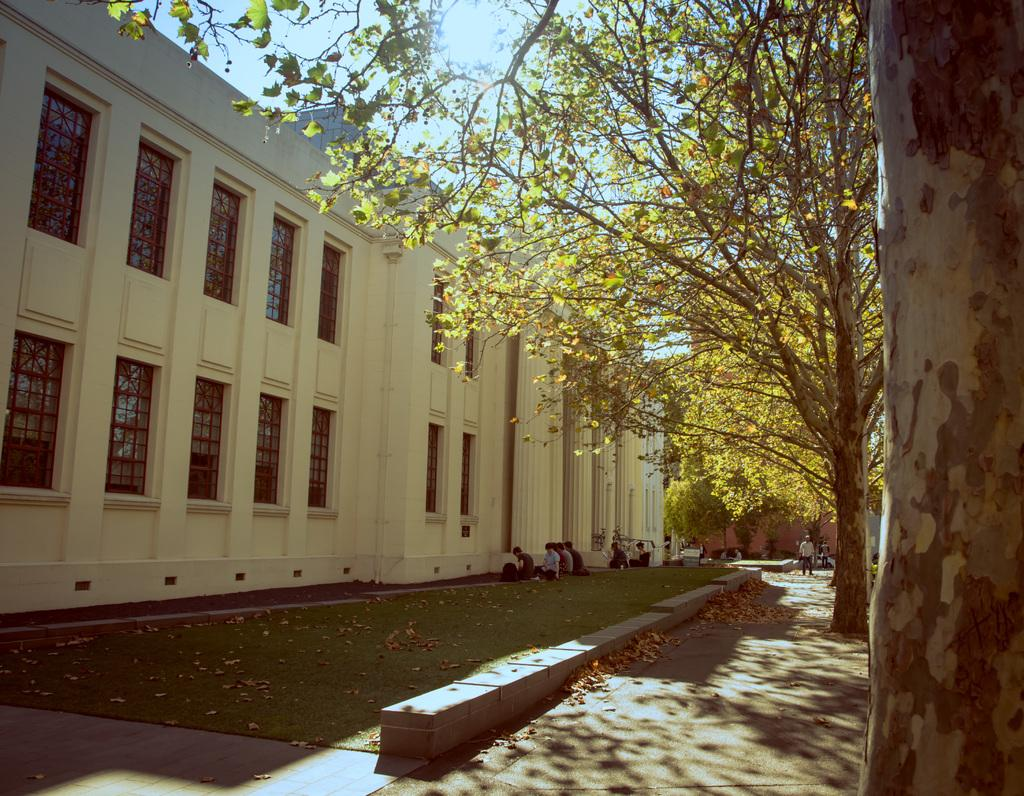Who or what can be seen in the image? There are people in the image. What can be seen on the ground in the image? There is a path and dry leaves visible on the ground in the image. What type of vegetation is present in the image? Trees are present in the image. What can be seen in the background of the image? There are buildings with windows and the sky visible in the background of the image. What type of fruit can be seen hanging from the trees in the image? There is no fruit visible in the image; only trees are present. How many chickens can be seen in the image? There are no chickens present in the image. 